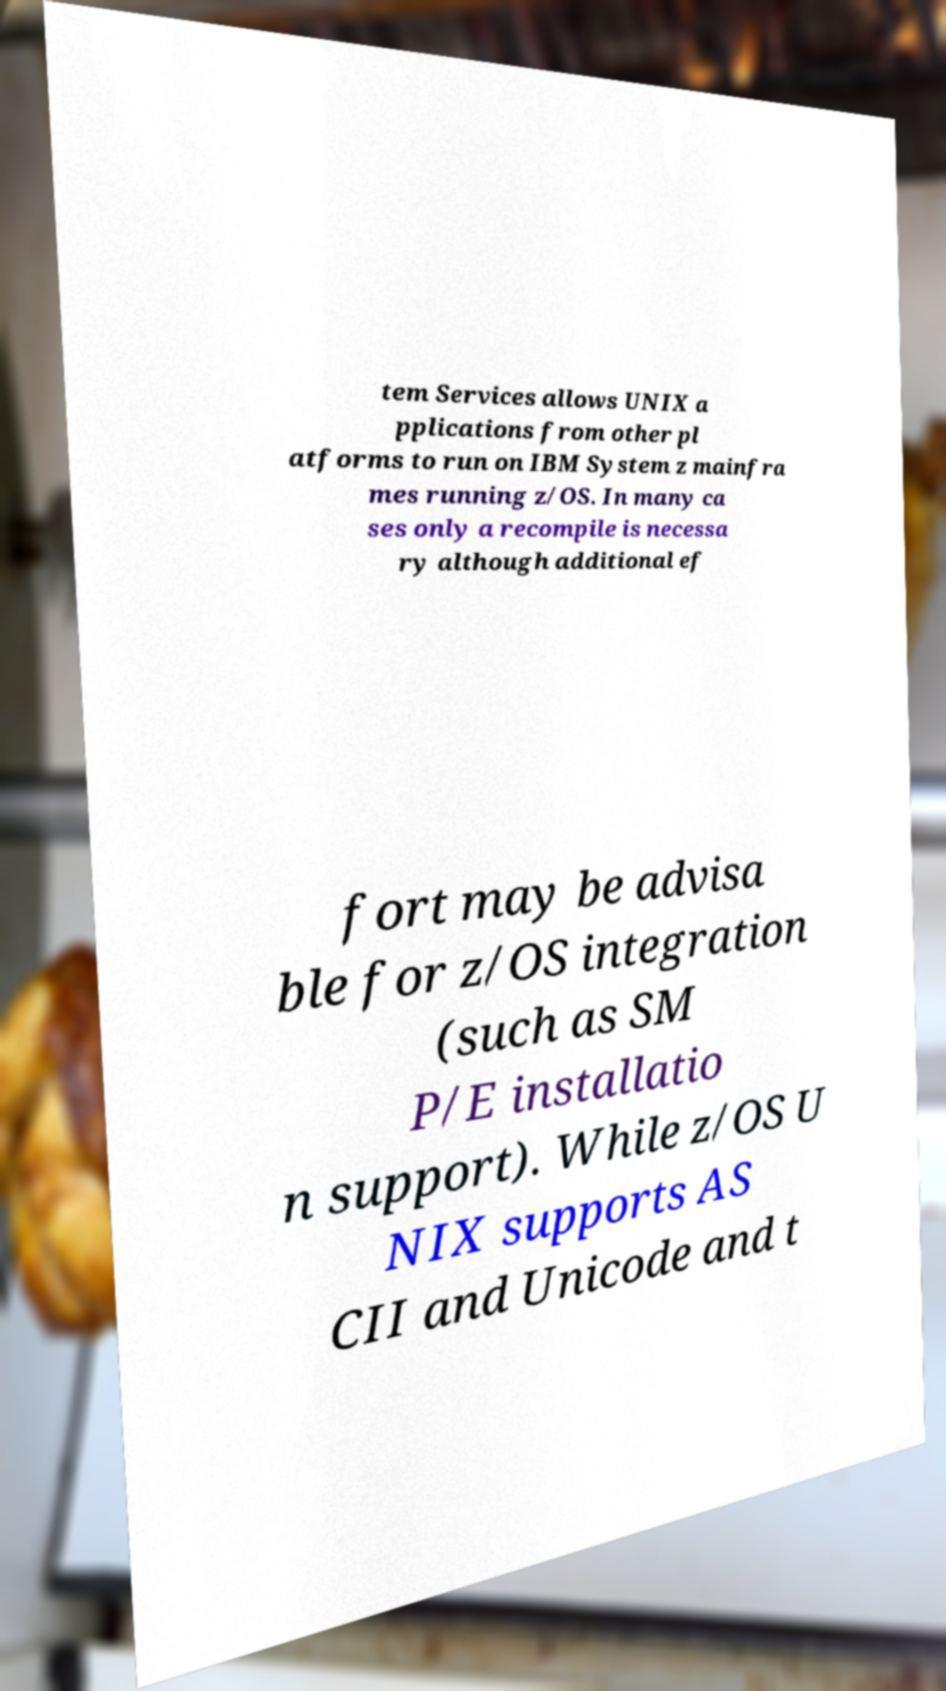I need the written content from this picture converted into text. Can you do that? tem Services allows UNIX a pplications from other pl atforms to run on IBM System z mainfra mes running z/OS. In many ca ses only a recompile is necessa ry although additional ef fort may be advisa ble for z/OS integration (such as SM P/E installatio n support). While z/OS U NIX supports AS CII and Unicode and t 